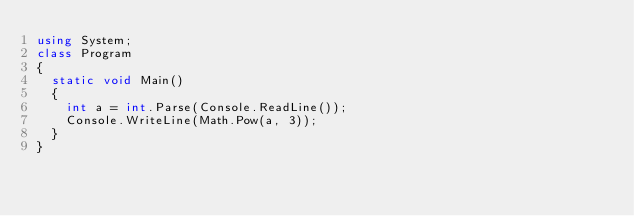<code> <loc_0><loc_0><loc_500><loc_500><_C#_>using System;
class Program
{
  static void Main()
  {
    int a = int.Parse(Console.ReadLine());    
    Console.WriteLine(Math.Pow(a, 3));            
  }
}
</code> 